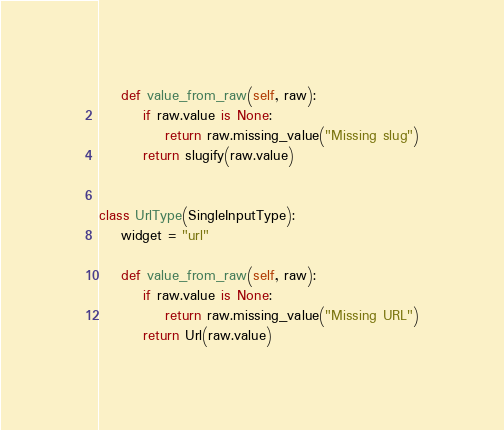Convert code to text. <code><loc_0><loc_0><loc_500><loc_500><_Python_>    def value_from_raw(self, raw):
        if raw.value is None:
            return raw.missing_value("Missing slug")
        return slugify(raw.value)


class UrlType(SingleInputType):
    widget = "url"

    def value_from_raw(self, raw):
        if raw.value is None:
            return raw.missing_value("Missing URL")
        return Url(raw.value)
</code> 